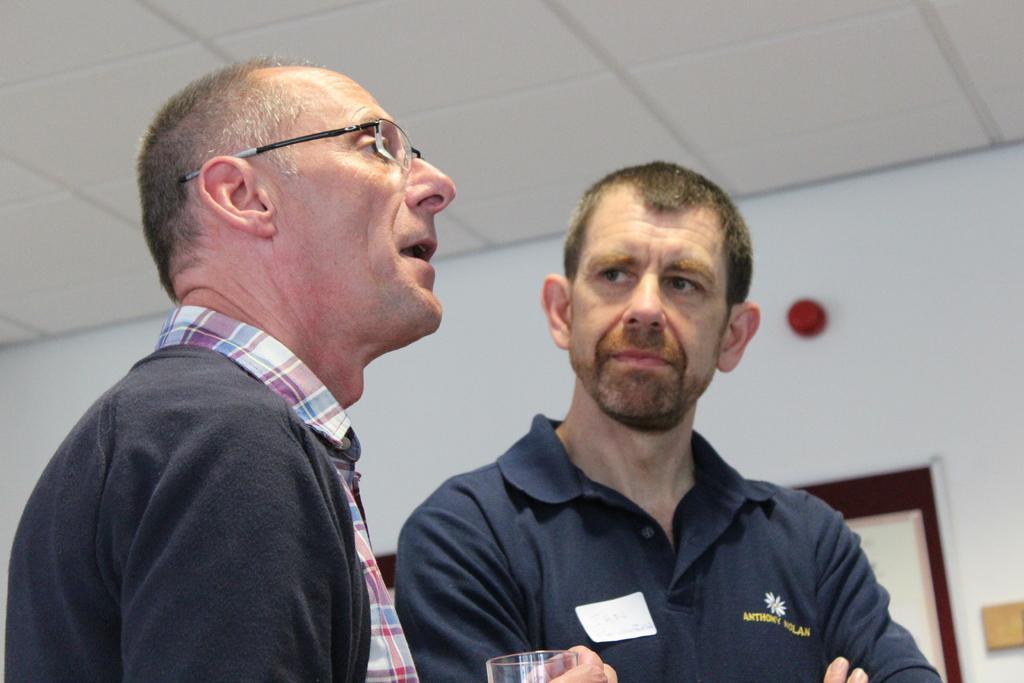In one or two sentences, can you explain what this image depicts? In the foreground of this image, there are two men standing and a man is holding a glass. In the background, it seems like a board on the wall and at the top, there is the ceiling. 